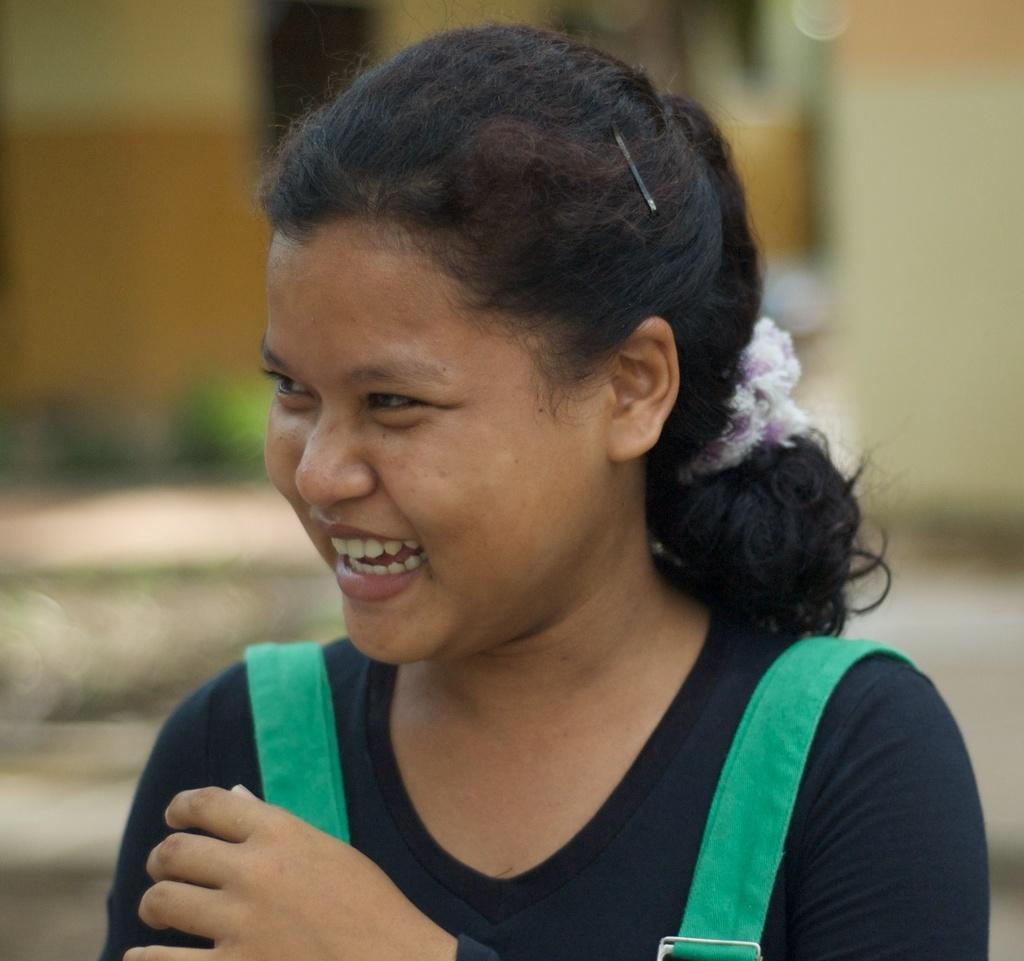Describe this image in one or two sentences. In this picture, we can see a lady laughing, and we can see the blurred background. 